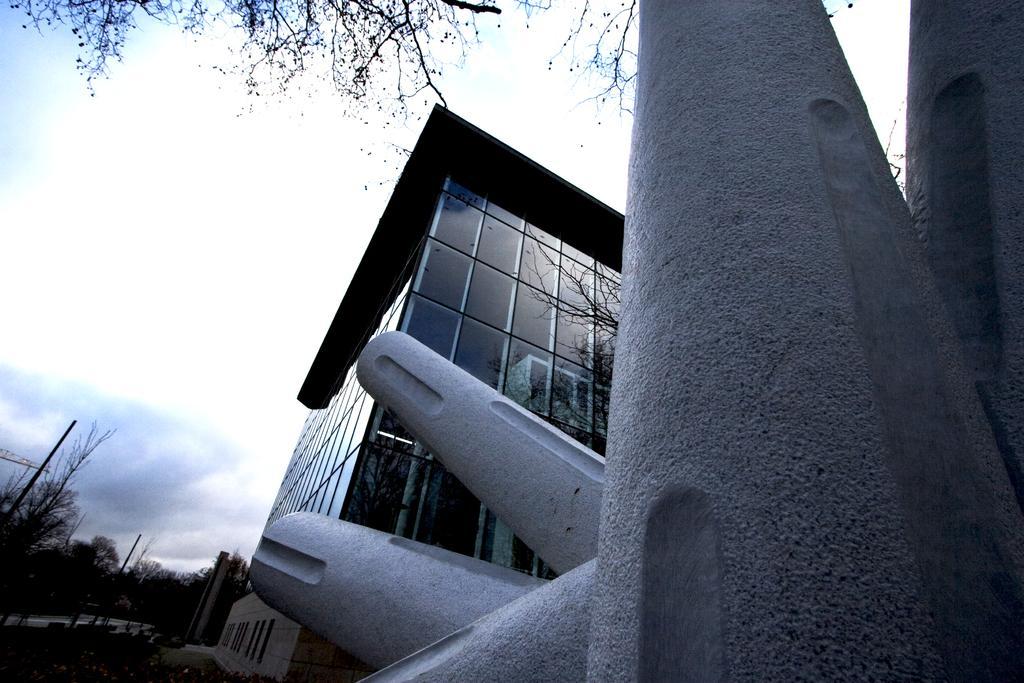Please provide a concise description of this image. In this image we can see a building. There is a reflection of trees and a building on the glasses of another building. There are many trees in the image. There are few poles in the image. There is a sky in the image. There is an object at the right side of the image. 